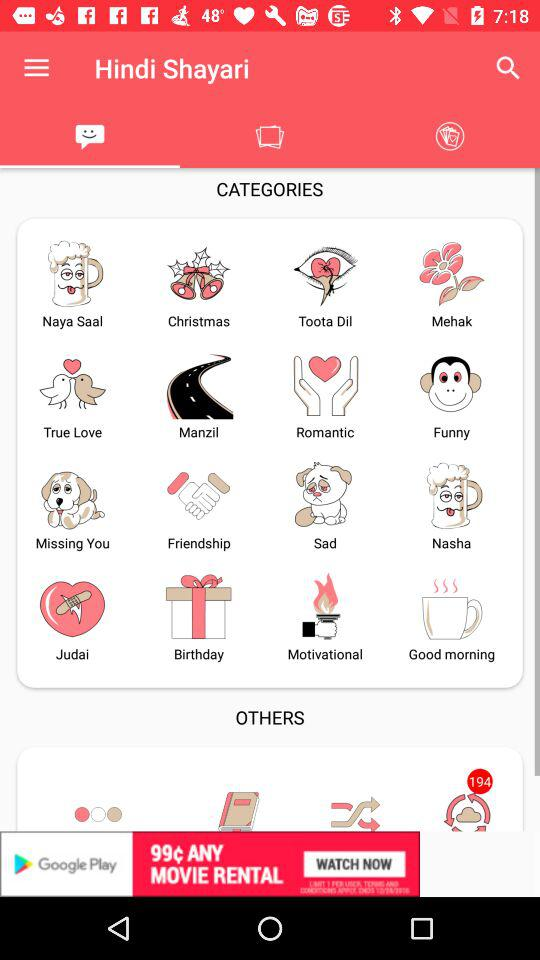What is the application name? The application name is "Hindi Shayari". 